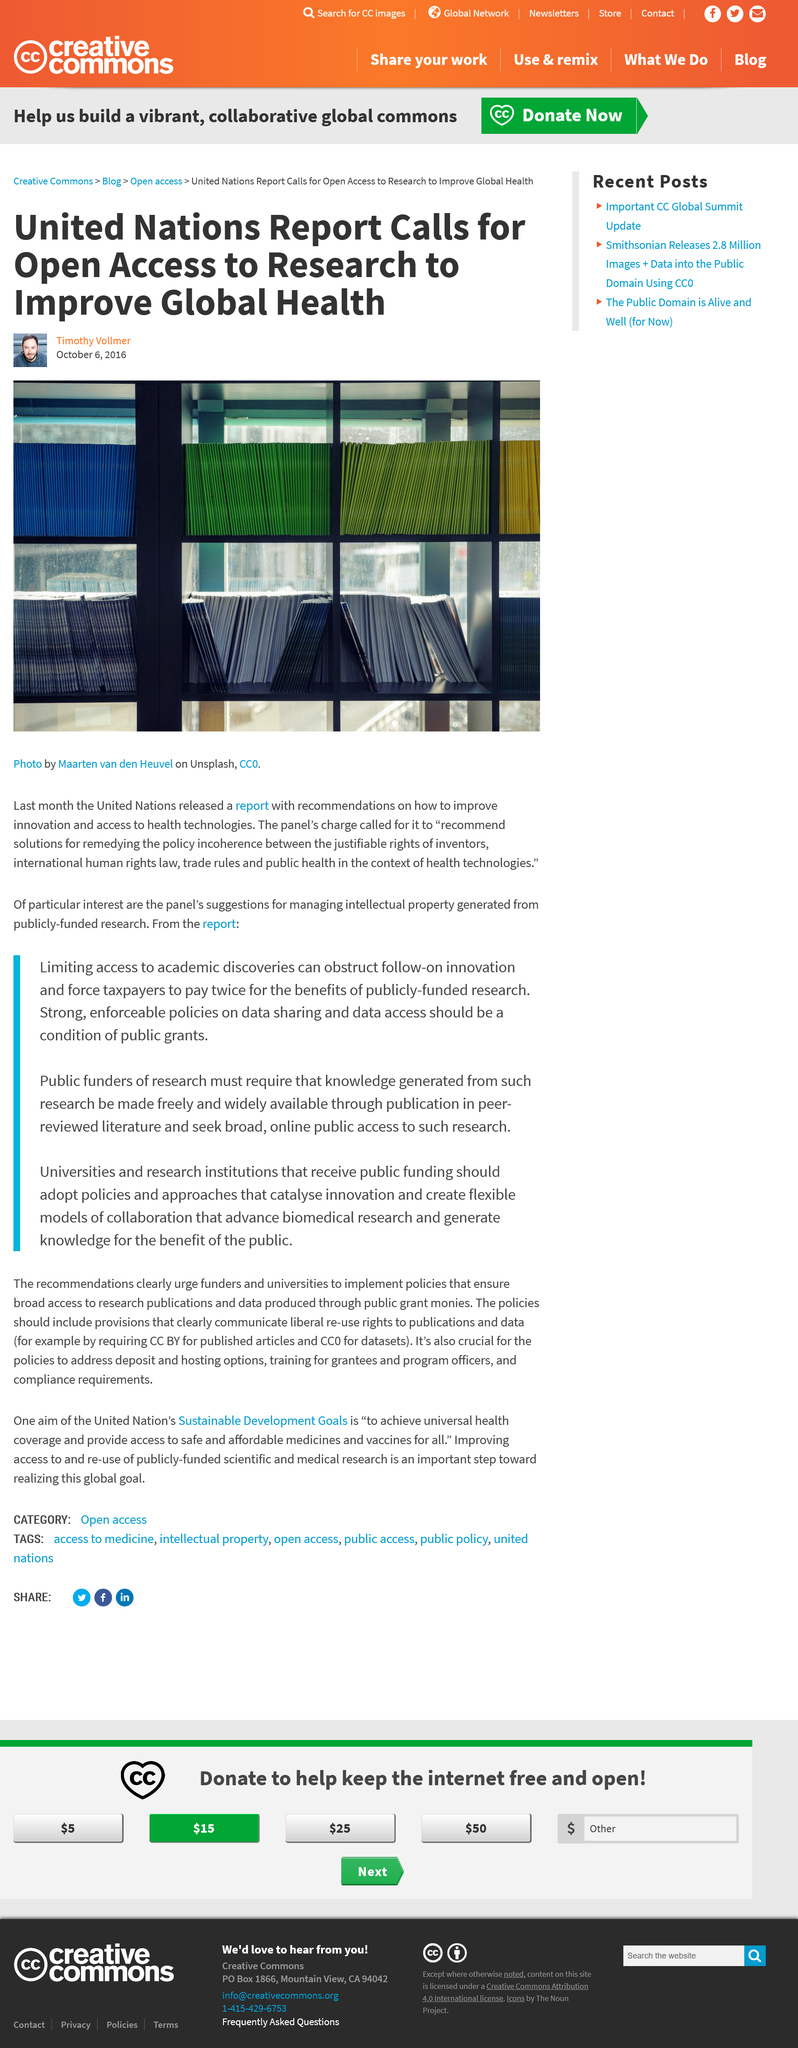Point out several critical features in this image. Maarten van den Heuvel took the photo. The article was created on October 6, 2016. A recent report from the United Nations has called for open access to research in order to improve global health. 